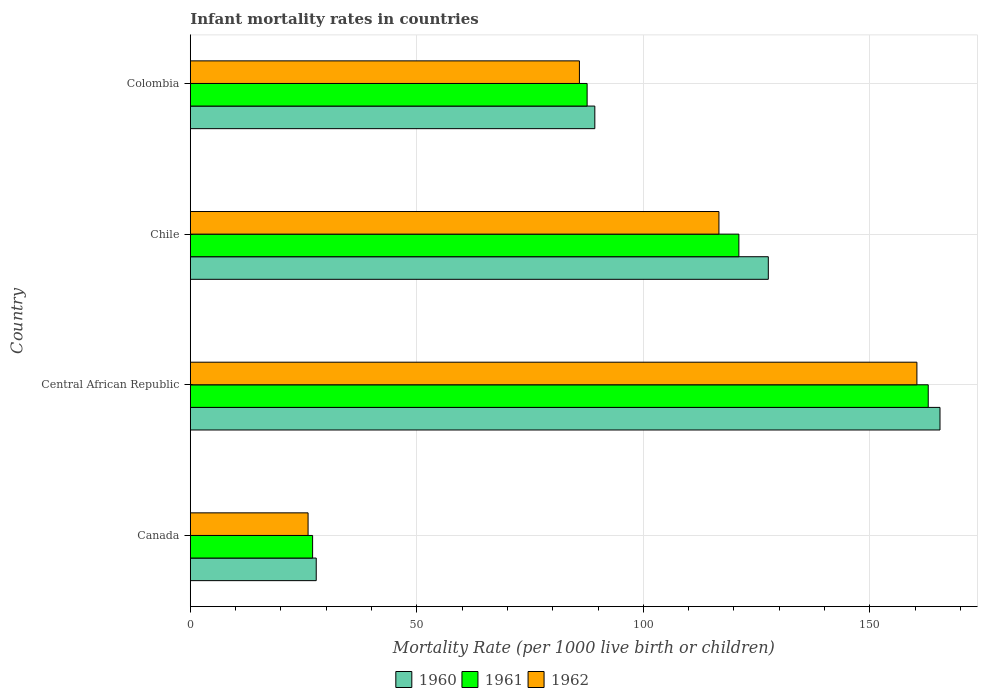How many different coloured bars are there?
Provide a short and direct response. 3. Are the number of bars per tick equal to the number of legend labels?
Provide a succinct answer. Yes. How many bars are there on the 3rd tick from the top?
Give a very brief answer. 3. What is the label of the 3rd group of bars from the top?
Make the answer very short. Central African Republic. In how many cases, is the number of bars for a given country not equal to the number of legend labels?
Your response must be concise. 0. What is the infant mortality rate in 1961 in Canada?
Your response must be concise. 27. Across all countries, what is the maximum infant mortality rate in 1960?
Provide a short and direct response. 165.5. Across all countries, what is the minimum infant mortality rate in 1961?
Give a very brief answer. 27. In which country was the infant mortality rate in 1960 maximum?
Your answer should be very brief. Central African Republic. What is the total infant mortality rate in 1960 in the graph?
Your answer should be very brief. 410.2. What is the difference between the infant mortality rate in 1962 in Central African Republic and that in Chile?
Give a very brief answer. 43.7. What is the difference between the infant mortality rate in 1960 in Canada and the infant mortality rate in 1961 in Colombia?
Make the answer very short. -59.8. What is the average infant mortality rate in 1960 per country?
Offer a terse response. 102.55. What is the difference between the infant mortality rate in 1962 and infant mortality rate in 1961 in Colombia?
Your answer should be very brief. -1.7. What is the ratio of the infant mortality rate in 1960 in Canada to that in Colombia?
Offer a very short reply. 0.31. Is the difference between the infant mortality rate in 1962 in Central African Republic and Colombia greater than the difference between the infant mortality rate in 1961 in Central African Republic and Colombia?
Keep it short and to the point. No. What is the difference between the highest and the second highest infant mortality rate in 1960?
Keep it short and to the point. 37.9. What is the difference between the highest and the lowest infant mortality rate in 1961?
Provide a short and direct response. 135.9. What does the 2nd bar from the bottom in Canada represents?
Ensure brevity in your answer.  1961. Is it the case that in every country, the sum of the infant mortality rate in 1962 and infant mortality rate in 1960 is greater than the infant mortality rate in 1961?
Offer a very short reply. Yes. How many bars are there?
Provide a short and direct response. 12. Does the graph contain any zero values?
Offer a very short reply. No. Does the graph contain grids?
Keep it short and to the point. Yes. How are the legend labels stacked?
Offer a terse response. Horizontal. What is the title of the graph?
Offer a very short reply. Infant mortality rates in countries. Does "2008" appear as one of the legend labels in the graph?
Provide a short and direct response. No. What is the label or title of the X-axis?
Your answer should be compact. Mortality Rate (per 1000 live birth or children). What is the label or title of the Y-axis?
Offer a very short reply. Country. What is the Mortality Rate (per 1000 live birth or children) of 1960 in Canada?
Make the answer very short. 27.8. What is the Mortality Rate (per 1000 live birth or children) in 1962 in Canada?
Offer a very short reply. 26. What is the Mortality Rate (per 1000 live birth or children) of 1960 in Central African Republic?
Make the answer very short. 165.5. What is the Mortality Rate (per 1000 live birth or children) in 1961 in Central African Republic?
Offer a very short reply. 162.9. What is the Mortality Rate (per 1000 live birth or children) of 1962 in Central African Republic?
Ensure brevity in your answer.  160.4. What is the Mortality Rate (per 1000 live birth or children) of 1960 in Chile?
Keep it short and to the point. 127.6. What is the Mortality Rate (per 1000 live birth or children) of 1961 in Chile?
Your response must be concise. 121.1. What is the Mortality Rate (per 1000 live birth or children) of 1962 in Chile?
Your answer should be compact. 116.7. What is the Mortality Rate (per 1000 live birth or children) in 1960 in Colombia?
Give a very brief answer. 89.3. What is the Mortality Rate (per 1000 live birth or children) in 1961 in Colombia?
Offer a terse response. 87.6. What is the Mortality Rate (per 1000 live birth or children) in 1962 in Colombia?
Make the answer very short. 85.9. Across all countries, what is the maximum Mortality Rate (per 1000 live birth or children) in 1960?
Your answer should be very brief. 165.5. Across all countries, what is the maximum Mortality Rate (per 1000 live birth or children) of 1961?
Make the answer very short. 162.9. Across all countries, what is the maximum Mortality Rate (per 1000 live birth or children) in 1962?
Provide a succinct answer. 160.4. Across all countries, what is the minimum Mortality Rate (per 1000 live birth or children) of 1960?
Your answer should be very brief. 27.8. What is the total Mortality Rate (per 1000 live birth or children) in 1960 in the graph?
Provide a short and direct response. 410.2. What is the total Mortality Rate (per 1000 live birth or children) in 1961 in the graph?
Give a very brief answer. 398.6. What is the total Mortality Rate (per 1000 live birth or children) of 1962 in the graph?
Your response must be concise. 389. What is the difference between the Mortality Rate (per 1000 live birth or children) of 1960 in Canada and that in Central African Republic?
Give a very brief answer. -137.7. What is the difference between the Mortality Rate (per 1000 live birth or children) in 1961 in Canada and that in Central African Republic?
Offer a terse response. -135.9. What is the difference between the Mortality Rate (per 1000 live birth or children) in 1962 in Canada and that in Central African Republic?
Ensure brevity in your answer.  -134.4. What is the difference between the Mortality Rate (per 1000 live birth or children) of 1960 in Canada and that in Chile?
Your answer should be very brief. -99.8. What is the difference between the Mortality Rate (per 1000 live birth or children) in 1961 in Canada and that in Chile?
Your answer should be very brief. -94.1. What is the difference between the Mortality Rate (per 1000 live birth or children) in 1962 in Canada and that in Chile?
Offer a very short reply. -90.7. What is the difference between the Mortality Rate (per 1000 live birth or children) in 1960 in Canada and that in Colombia?
Keep it short and to the point. -61.5. What is the difference between the Mortality Rate (per 1000 live birth or children) in 1961 in Canada and that in Colombia?
Your response must be concise. -60.6. What is the difference between the Mortality Rate (per 1000 live birth or children) in 1962 in Canada and that in Colombia?
Your answer should be very brief. -59.9. What is the difference between the Mortality Rate (per 1000 live birth or children) in 1960 in Central African Republic and that in Chile?
Your answer should be compact. 37.9. What is the difference between the Mortality Rate (per 1000 live birth or children) of 1961 in Central African Republic and that in Chile?
Provide a succinct answer. 41.8. What is the difference between the Mortality Rate (per 1000 live birth or children) in 1962 in Central African Republic and that in Chile?
Give a very brief answer. 43.7. What is the difference between the Mortality Rate (per 1000 live birth or children) of 1960 in Central African Republic and that in Colombia?
Ensure brevity in your answer.  76.2. What is the difference between the Mortality Rate (per 1000 live birth or children) of 1961 in Central African Republic and that in Colombia?
Offer a terse response. 75.3. What is the difference between the Mortality Rate (per 1000 live birth or children) in 1962 in Central African Republic and that in Colombia?
Your response must be concise. 74.5. What is the difference between the Mortality Rate (per 1000 live birth or children) of 1960 in Chile and that in Colombia?
Keep it short and to the point. 38.3. What is the difference between the Mortality Rate (per 1000 live birth or children) in 1961 in Chile and that in Colombia?
Offer a very short reply. 33.5. What is the difference between the Mortality Rate (per 1000 live birth or children) of 1962 in Chile and that in Colombia?
Ensure brevity in your answer.  30.8. What is the difference between the Mortality Rate (per 1000 live birth or children) of 1960 in Canada and the Mortality Rate (per 1000 live birth or children) of 1961 in Central African Republic?
Your response must be concise. -135.1. What is the difference between the Mortality Rate (per 1000 live birth or children) in 1960 in Canada and the Mortality Rate (per 1000 live birth or children) in 1962 in Central African Republic?
Your answer should be very brief. -132.6. What is the difference between the Mortality Rate (per 1000 live birth or children) of 1961 in Canada and the Mortality Rate (per 1000 live birth or children) of 1962 in Central African Republic?
Your answer should be very brief. -133.4. What is the difference between the Mortality Rate (per 1000 live birth or children) in 1960 in Canada and the Mortality Rate (per 1000 live birth or children) in 1961 in Chile?
Provide a succinct answer. -93.3. What is the difference between the Mortality Rate (per 1000 live birth or children) of 1960 in Canada and the Mortality Rate (per 1000 live birth or children) of 1962 in Chile?
Your answer should be compact. -88.9. What is the difference between the Mortality Rate (per 1000 live birth or children) of 1961 in Canada and the Mortality Rate (per 1000 live birth or children) of 1962 in Chile?
Offer a very short reply. -89.7. What is the difference between the Mortality Rate (per 1000 live birth or children) in 1960 in Canada and the Mortality Rate (per 1000 live birth or children) in 1961 in Colombia?
Give a very brief answer. -59.8. What is the difference between the Mortality Rate (per 1000 live birth or children) in 1960 in Canada and the Mortality Rate (per 1000 live birth or children) in 1962 in Colombia?
Keep it short and to the point. -58.1. What is the difference between the Mortality Rate (per 1000 live birth or children) of 1961 in Canada and the Mortality Rate (per 1000 live birth or children) of 1962 in Colombia?
Your answer should be compact. -58.9. What is the difference between the Mortality Rate (per 1000 live birth or children) of 1960 in Central African Republic and the Mortality Rate (per 1000 live birth or children) of 1961 in Chile?
Your response must be concise. 44.4. What is the difference between the Mortality Rate (per 1000 live birth or children) in 1960 in Central African Republic and the Mortality Rate (per 1000 live birth or children) in 1962 in Chile?
Keep it short and to the point. 48.8. What is the difference between the Mortality Rate (per 1000 live birth or children) of 1961 in Central African Republic and the Mortality Rate (per 1000 live birth or children) of 1962 in Chile?
Your answer should be compact. 46.2. What is the difference between the Mortality Rate (per 1000 live birth or children) of 1960 in Central African Republic and the Mortality Rate (per 1000 live birth or children) of 1961 in Colombia?
Offer a terse response. 77.9. What is the difference between the Mortality Rate (per 1000 live birth or children) in 1960 in Central African Republic and the Mortality Rate (per 1000 live birth or children) in 1962 in Colombia?
Provide a succinct answer. 79.6. What is the difference between the Mortality Rate (per 1000 live birth or children) of 1960 in Chile and the Mortality Rate (per 1000 live birth or children) of 1961 in Colombia?
Keep it short and to the point. 40. What is the difference between the Mortality Rate (per 1000 live birth or children) of 1960 in Chile and the Mortality Rate (per 1000 live birth or children) of 1962 in Colombia?
Provide a succinct answer. 41.7. What is the difference between the Mortality Rate (per 1000 live birth or children) of 1961 in Chile and the Mortality Rate (per 1000 live birth or children) of 1962 in Colombia?
Offer a terse response. 35.2. What is the average Mortality Rate (per 1000 live birth or children) in 1960 per country?
Your answer should be very brief. 102.55. What is the average Mortality Rate (per 1000 live birth or children) in 1961 per country?
Make the answer very short. 99.65. What is the average Mortality Rate (per 1000 live birth or children) of 1962 per country?
Ensure brevity in your answer.  97.25. What is the difference between the Mortality Rate (per 1000 live birth or children) in 1960 and Mortality Rate (per 1000 live birth or children) in 1961 in Canada?
Make the answer very short. 0.8. What is the difference between the Mortality Rate (per 1000 live birth or children) in 1961 and Mortality Rate (per 1000 live birth or children) in 1962 in Canada?
Your answer should be very brief. 1. What is the difference between the Mortality Rate (per 1000 live birth or children) of 1960 and Mortality Rate (per 1000 live birth or children) of 1962 in Central African Republic?
Your answer should be compact. 5.1. What is the difference between the Mortality Rate (per 1000 live birth or children) of 1960 and Mortality Rate (per 1000 live birth or children) of 1961 in Chile?
Your answer should be very brief. 6.5. What is the difference between the Mortality Rate (per 1000 live birth or children) in 1961 and Mortality Rate (per 1000 live birth or children) in 1962 in Chile?
Offer a terse response. 4.4. What is the difference between the Mortality Rate (per 1000 live birth or children) of 1960 and Mortality Rate (per 1000 live birth or children) of 1961 in Colombia?
Provide a succinct answer. 1.7. What is the ratio of the Mortality Rate (per 1000 live birth or children) of 1960 in Canada to that in Central African Republic?
Offer a terse response. 0.17. What is the ratio of the Mortality Rate (per 1000 live birth or children) of 1961 in Canada to that in Central African Republic?
Provide a succinct answer. 0.17. What is the ratio of the Mortality Rate (per 1000 live birth or children) of 1962 in Canada to that in Central African Republic?
Your response must be concise. 0.16. What is the ratio of the Mortality Rate (per 1000 live birth or children) of 1960 in Canada to that in Chile?
Keep it short and to the point. 0.22. What is the ratio of the Mortality Rate (per 1000 live birth or children) of 1961 in Canada to that in Chile?
Ensure brevity in your answer.  0.22. What is the ratio of the Mortality Rate (per 1000 live birth or children) in 1962 in Canada to that in Chile?
Your answer should be very brief. 0.22. What is the ratio of the Mortality Rate (per 1000 live birth or children) in 1960 in Canada to that in Colombia?
Keep it short and to the point. 0.31. What is the ratio of the Mortality Rate (per 1000 live birth or children) of 1961 in Canada to that in Colombia?
Offer a terse response. 0.31. What is the ratio of the Mortality Rate (per 1000 live birth or children) in 1962 in Canada to that in Colombia?
Provide a succinct answer. 0.3. What is the ratio of the Mortality Rate (per 1000 live birth or children) of 1960 in Central African Republic to that in Chile?
Offer a very short reply. 1.3. What is the ratio of the Mortality Rate (per 1000 live birth or children) of 1961 in Central African Republic to that in Chile?
Offer a very short reply. 1.35. What is the ratio of the Mortality Rate (per 1000 live birth or children) of 1962 in Central African Republic to that in Chile?
Provide a short and direct response. 1.37. What is the ratio of the Mortality Rate (per 1000 live birth or children) in 1960 in Central African Republic to that in Colombia?
Offer a terse response. 1.85. What is the ratio of the Mortality Rate (per 1000 live birth or children) in 1961 in Central African Republic to that in Colombia?
Provide a short and direct response. 1.86. What is the ratio of the Mortality Rate (per 1000 live birth or children) in 1962 in Central African Republic to that in Colombia?
Give a very brief answer. 1.87. What is the ratio of the Mortality Rate (per 1000 live birth or children) of 1960 in Chile to that in Colombia?
Provide a succinct answer. 1.43. What is the ratio of the Mortality Rate (per 1000 live birth or children) of 1961 in Chile to that in Colombia?
Offer a very short reply. 1.38. What is the ratio of the Mortality Rate (per 1000 live birth or children) in 1962 in Chile to that in Colombia?
Your response must be concise. 1.36. What is the difference between the highest and the second highest Mortality Rate (per 1000 live birth or children) in 1960?
Provide a short and direct response. 37.9. What is the difference between the highest and the second highest Mortality Rate (per 1000 live birth or children) in 1961?
Your answer should be very brief. 41.8. What is the difference between the highest and the second highest Mortality Rate (per 1000 live birth or children) in 1962?
Offer a very short reply. 43.7. What is the difference between the highest and the lowest Mortality Rate (per 1000 live birth or children) of 1960?
Your answer should be very brief. 137.7. What is the difference between the highest and the lowest Mortality Rate (per 1000 live birth or children) of 1961?
Provide a succinct answer. 135.9. What is the difference between the highest and the lowest Mortality Rate (per 1000 live birth or children) in 1962?
Keep it short and to the point. 134.4. 